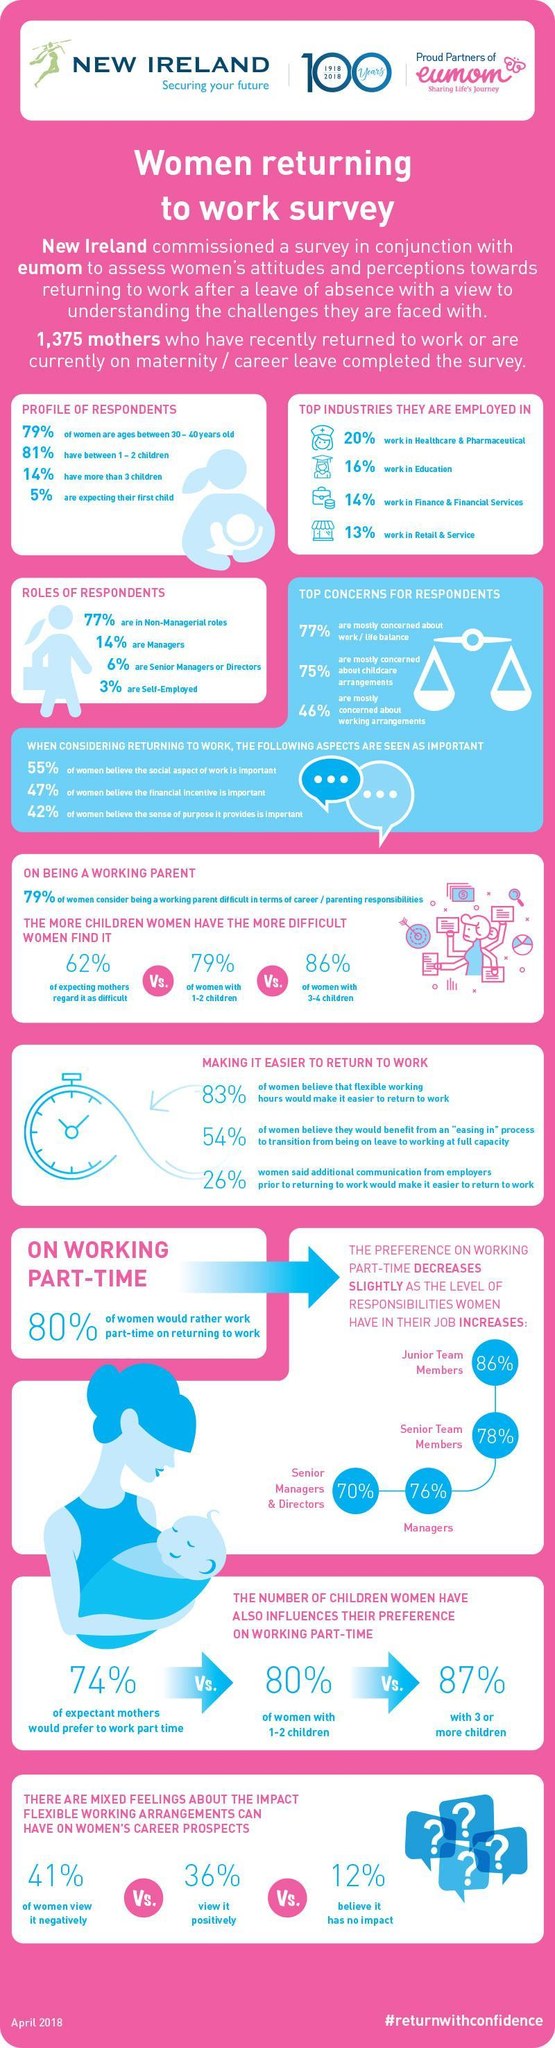Which industry has most number of mothers working in?
Answer the question with a short phrase. Healthcare & Pharmaceutical What percent of respondents work on their own? 3% What is the hashtag given? #returnwithconfidence What percent of respondents are managers, senior managers or directors? 20% 